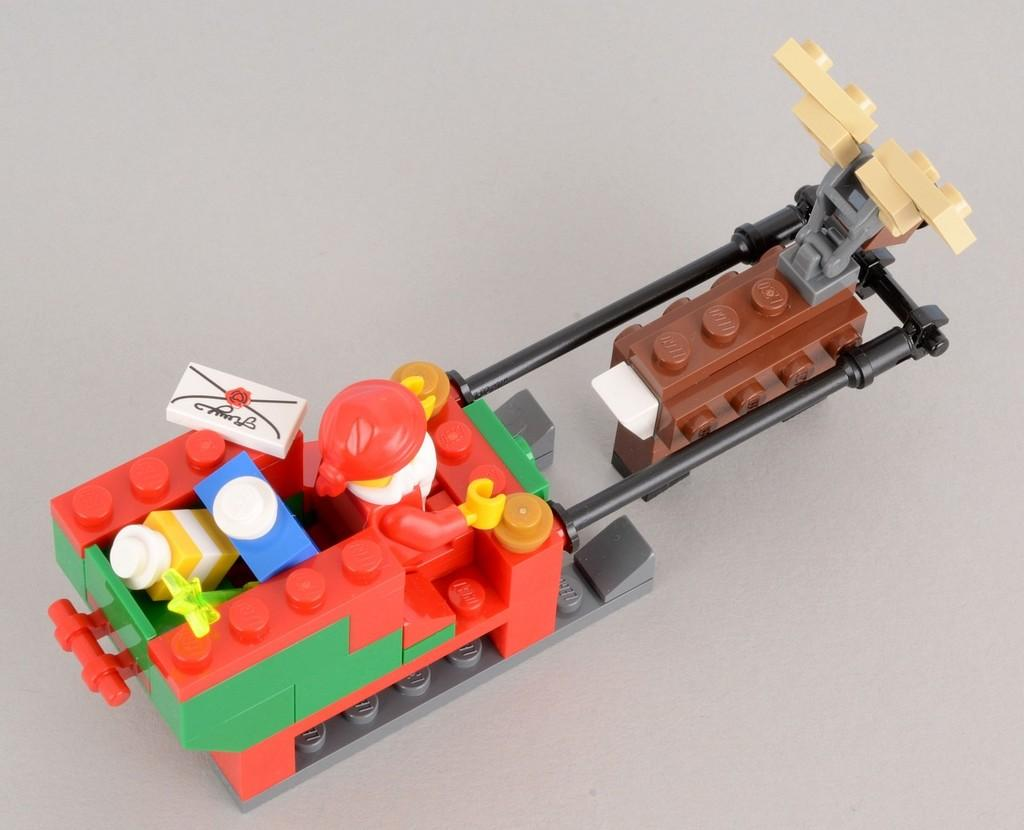What type of toy is featured in the image? The image contains a lego puzzle toy. Can you describe the toy in more detail? The lego puzzle toy consists of interlocking plastic bricks that can be assembled and disassembled to create various structures or designs. What type of cake is being decorated with a stamp in the image? There is no cake or stamp present in the image; it features a lego puzzle toy. 